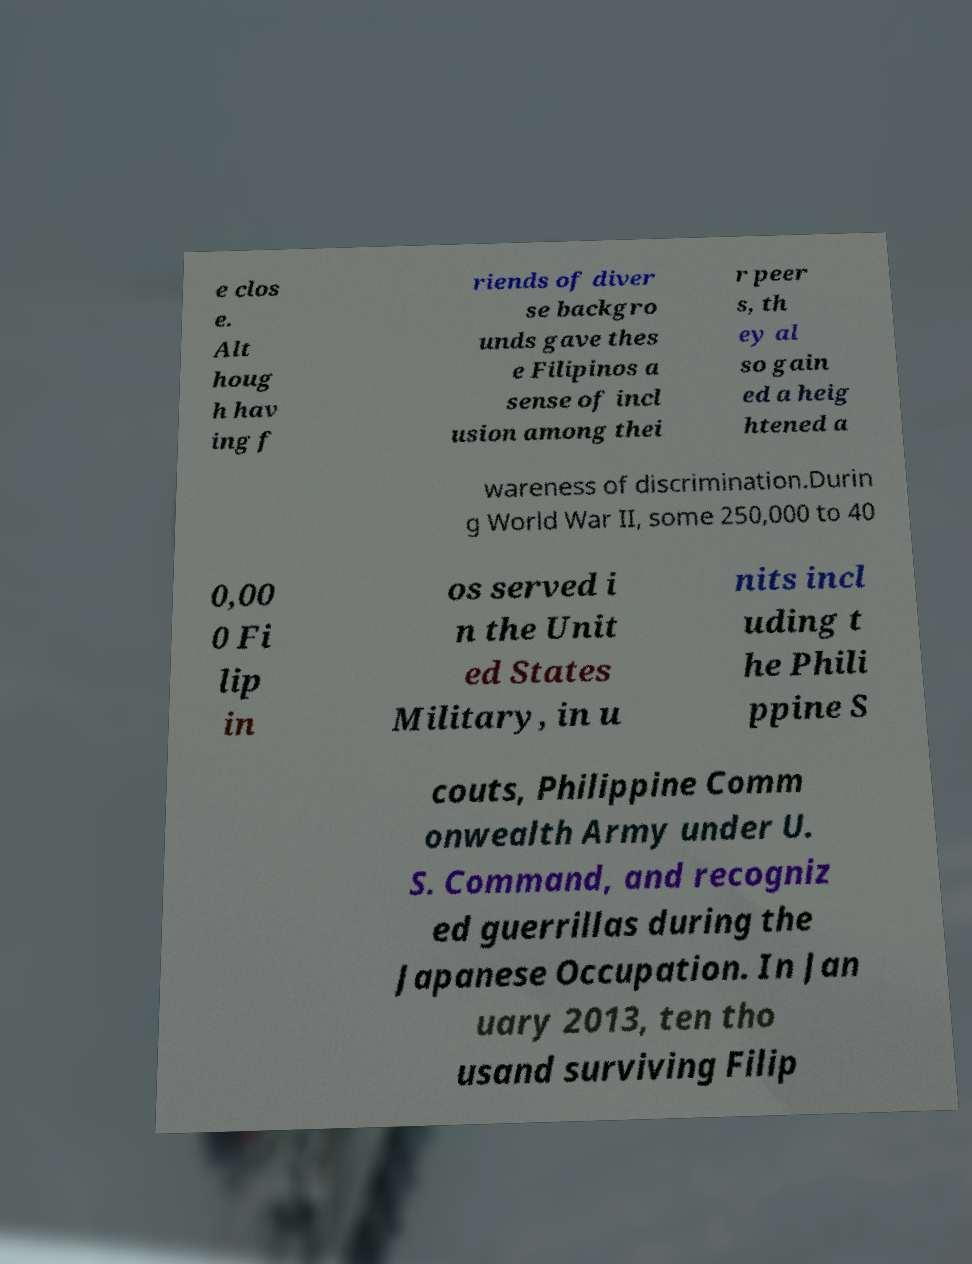There's text embedded in this image that I need extracted. Can you transcribe it verbatim? e clos e. Alt houg h hav ing f riends of diver se backgro unds gave thes e Filipinos a sense of incl usion among thei r peer s, th ey al so gain ed a heig htened a wareness of discrimination.Durin g World War II, some 250,000 to 40 0,00 0 Fi lip in os served i n the Unit ed States Military, in u nits incl uding t he Phili ppine S couts, Philippine Comm onwealth Army under U. S. Command, and recogniz ed guerrillas during the Japanese Occupation. In Jan uary 2013, ten tho usand surviving Filip 